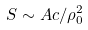Convert formula to latex. <formula><loc_0><loc_0><loc_500><loc_500>S \sim A c / { \rho _ { 0 } ^ { 2 } }</formula> 